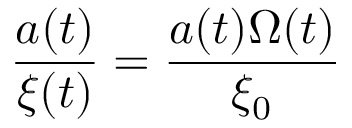<formula> <loc_0><loc_0><loc_500><loc_500>\frac { a ( t ) } { \xi ( t ) } = \frac { a ( t ) \Omega ( t ) } { \xi _ { 0 } }</formula> 